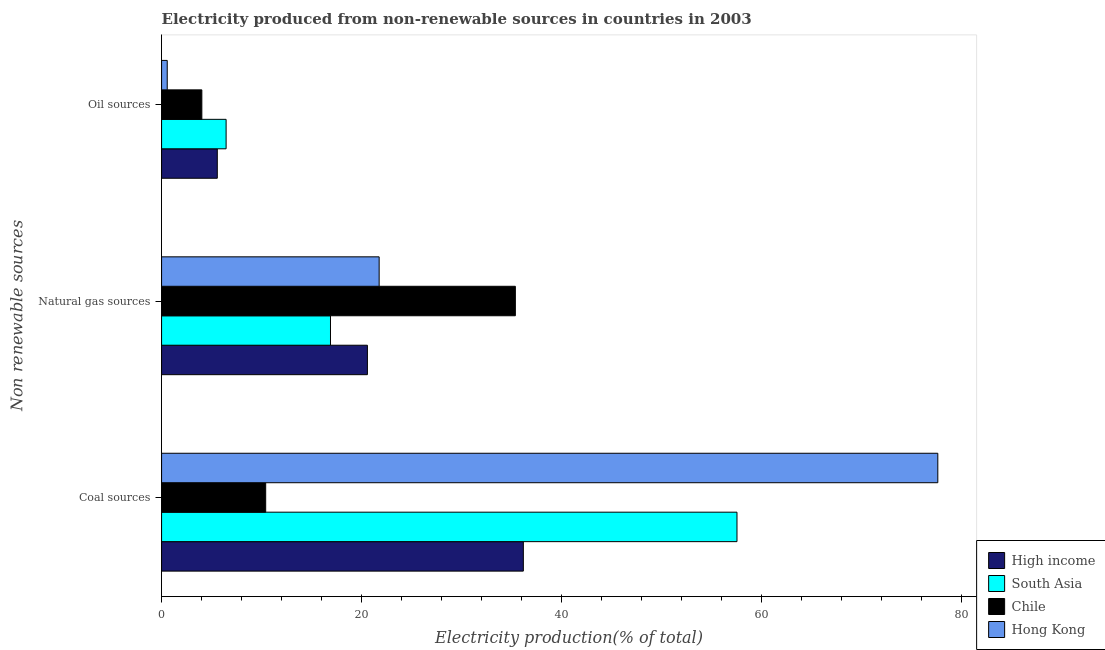How many groups of bars are there?
Give a very brief answer. 3. Are the number of bars on each tick of the Y-axis equal?
Provide a short and direct response. Yes. How many bars are there on the 2nd tick from the top?
Ensure brevity in your answer.  4. What is the label of the 1st group of bars from the top?
Your answer should be very brief. Oil sources. What is the percentage of electricity produced by coal in Chile?
Provide a succinct answer. 10.42. Across all countries, what is the maximum percentage of electricity produced by coal?
Make the answer very short. 77.66. Across all countries, what is the minimum percentage of electricity produced by coal?
Make the answer very short. 10.42. In which country was the percentage of electricity produced by coal maximum?
Provide a short and direct response. Hong Kong. What is the total percentage of electricity produced by natural gas in the graph?
Your answer should be very brief. 94.66. What is the difference between the percentage of electricity produced by coal in Hong Kong and that in High income?
Your response must be concise. 41.47. What is the difference between the percentage of electricity produced by oil sources in South Asia and the percentage of electricity produced by coal in Hong Kong?
Your answer should be very brief. -71.21. What is the average percentage of electricity produced by oil sources per country?
Provide a short and direct response. 4.16. What is the difference between the percentage of electricity produced by coal and percentage of electricity produced by natural gas in South Asia?
Your answer should be compact. 40.67. In how many countries, is the percentage of electricity produced by coal greater than 64 %?
Give a very brief answer. 1. What is the ratio of the percentage of electricity produced by natural gas in South Asia to that in Hong Kong?
Your response must be concise. 0.78. What is the difference between the highest and the second highest percentage of electricity produced by coal?
Your answer should be compact. 20.09. What is the difference between the highest and the lowest percentage of electricity produced by oil sources?
Your answer should be very brief. 5.89. Is the sum of the percentage of electricity produced by coal in Chile and High income greater than the maximum percentage of electricity produced by natural gas across all countries?
Provide a short and direct response. Yes. What does the 1st bar from the top in Coal sources represents?
Ensure brevity in your answer.  Hong Kong. How many countries are there in the graph?
Offer a very short reply. 4. What is the difference between two consecutive major ticks on the X-axis?
Your answer should be very brief. 20. Does the graph contain grids?
Keep it short and to the point. No. What is the title of the graph?
Your answer should be very brief. Electricity produced from non-renewable sources in countries in 2003. What is the label or title of the Y-axis?
Provide a succinct answer. Non renewable sources. What is the Electricity production(% of total) of High income in Coal sources?
Offer a very short reply. 36.2. What is the Electricity production(% of total) in South Asia in Coal sources?
Offer a very short reply. 57.57. What is the Electricity production(% of total) of Chile in Coal sources?
Provide a short and direct response. 10.42. What is the Electricity production(% of total) in Hong Kong in Coal sources?
Your answer should be compact. 77.66. What is the Electricity production(% of total) in High income in Natural gas sources?
Keep it short and to the point. 20.59. What is the Electricity production(% of total) in South Asia in Natural gas sources?
Your answer should be compact. 16.9. What is the Electricity production(% of total) of Chile in Natural gas sources?
Your answer should be very brief. 35.4. What is the Electricity production(% of total) in Hong Kong in Natural gas sources?
Your response must be concise. 21.77. What is the Electricity production(% of total) in High income in Oil sources?
Offer a very short reply. 5.58. What is the Electricity production(% of total) of South Asia in Oil sources?
Provide a short and direct response. 6.46. What is the Electricity production(% of total) in Chile in Oil sources?
Give a very brief answer. 4.03. What is the Electricity production(% of total) of Hong Kong in Oil sources?
Your response must be concise. 0.57. Across all Non renewable sources, what is the maximum Electricity production(% of total) of High income?
Keep it short and to the point. 36.2. Across all Non renewable sources, what is the maximum Electricity production(% of total) in South Asia?
Your response must be concise. 57.57. Across all Non renewable sources, what is the maximum Electricity production(% of total) of Chile?
Keep it short and to the point. 35.4. Across all Non renewable sources, what is the maximum Electricity production(% of total) in Hong Kong?
Offer a very short reply. 77.66. Across all Non renewable sources, what is the minimum Electricity production(% of total) in High income?
Provide a succinct answer. 5.58. Across all Non renewable sources, what is the minimum Electricity production(% of total) of South Asia?
Offer a terse response. 6.46. Across all Non renewable sources, what is the minimum Electricity production(% of total) of Chile?
Give a very brief answer. 4.03. Across all Non renewable sources, what is the minimum Electricity production(% of total) of Hong Kong?
Make the answer very short. 0.57. What is the total Electricity production(% of total) of High income in the graph?
Provide a short and direct response. 62.37. What is the total Electricity production(% of total) of South Asia in the graph?
Your response must be concise. 80.93. What is the total Electricity production(% of total) of Chile in the graph?
Your response must be concise. 49.84. What is the difference between the Electricity production(% of total) of High income in Coal sources and that in Natural gas sources?
Give a very brief answer. 15.6. What is the difference between the Electricity production(% of total) in South Asia in Coal sources and that in Natural gas sources?
Provide a succinct answer. 40.67. What is the difference between the Electricity production(% of total) in Chile in Coal sources and that in Natural gas sources?
Your answer should be compact. -24.98. What is the difference between the Electricity production(% of total) of Hong Kong in Coal sources and that in Natural gas sources?
Provide a short and direct response. 55.9. What is the difference between the Electricity production(% of total) of High income in Coal sources and that in Oil sources?
Provide a succinct answer. 30.62. What is the difference between the Electricity production(% of total) in South Asia in Coal sources and that in Oil sources?
Offer a very short reply. 51.11. What is the difference between the Electricity production(% of total) of Chile in Coal sources and that in Oil sources?
Keep it short and to the point. 6.39. What is the difference between the Electricity production(% of total) in Hong Kong in Coal sources and that in Oil sources?
Make the answer very short. 77.1. What is the difference between the Electricity production(% of total) of High income in Natural gas sources and that in Oil sources?
Your response must be concise. 15.02. What is the difference between the Electricity production(% of total) of South Asia in Natural gas sources and that in Oil sources?
Make the answer very short. 10.44. What is the difference between the Electricity production(% of total) of Chile in Natural gas sources and that in Oil sources?
Give a very brief answer. 31.37. What is the difference between the Electricity production(% of total) in Hong Kong in Natural gas sources and that in Oil sources?
Offer a terse response. 21.2. What is the difference between the Electricity production(% of total) in High income in Coal sources and the Electricity production(% of total) in South Asia in Natural gas sources?
Give a very brief answer. 19.3. What is the difference between the Electricity production(% of total) in High income in Coal sources and the Electricity production(% of total) in Chile in Natural gas sources?
Ensure brevity in your answer.  0.8. What is the difference between the Electricity production(% of total) in High income in Coal sources and the Electricity production(% of total) in Hong Kong in Natural gas sources?
Your answer should be compact. 14.43. What is the difference between the Electricity production(% of total) in South Asia in Coal sources and the Electricity production(% of total) in Chile in Natural gas sources?
Provide a succinct answer. 22.17. What is the difference between the Electricity production(% of total) in South Asia in Coal sources and the Electricity production(% of total) in Hong Kong in Natural gas sources?
Keep it short and to the point. 35.8. What is the difference between the Electricity production(% of total) in Chile in Coal sources and the Electricity production(% of total) in Hong Kong in Natural gas sources?
Your answer should be very brief. -11.35. What is the difference between the Electricity production(% of total) of High income in Coal sources and the Electricity production(% of total) of South Asia in Oil sources?
Provide a short and direct response. 29.74. What is the difference between the Electricity production(% of total) in High income in Coal sources and the Electricity production(% of total) in Chile in Oil sources?
Offer a very short reply. 32.17. What is the difference between the Electricity production(% of total) of High income in Coal sources and the Electricity production(% of total) of Hong Kong in Oil sources?
Ensure brevity in your answer.  35.63. What is the difference between the Electricity production(% of total) in South Asia in Coal sources and the Electricity production(% of total) in Chile in Oil sources?
Give a very brief answer. 53.54. What is the difference between the Electricity production(% of total) in South Asia in Coal sources and the Electricity production(% of total) in Hong Kong in Oil sources?
Your answer should be very brief. 57.01. What is the difference between the Electricity production(% of total) in Chile in Coal sources and the Electricity production(% of total) in Hong Kong in Oil sources?
Offer a very short reply. 9.85. What is the difference between the Electricity production(% of total) of High income in Natural gas sources and the Electricity production(% of total) of South Asia in Oil sources?
Your answer should be compact. 14.14. What is the difference between the Electricity production(% of total) in High income in Natural gas sources and the Electricity production(% of total) in Chile in Oil sources?
Offer a very short reply. 16.57. What is the difference between the Electricity production(% of total) of High income in Natural gas sources and the Electricity production(% of total) of Hong Kong in Oil sources?
Offer a terse response. 20.03. What is the difference between the Electricity production(% of total) of South Asia in Natural gas sources and the Electricity production(% of total) of Chile in Oil sources?
Offer a terse response. 12.87. What is the difference between the Electricity production(% of total) in South Asia in Natural gas sources and the Electricity production(% of total) in Hong Kong in Oil sources?
Your answer should be compact. 16.33. What is the difference between the Electricity production(% of total) in Chile in Natural gas sources and the Electricity production(% of total) in Hong Kong in Oil sources?
Provide a succinct answer. 34.83. What is the average Electricity production(% of total) in High income per Non renewable sources?
Your answer should be very brief. 20.79. What is the average Electricity production(% of total) of South Asia per Non renewable sources?
Offer a very short reply. 26.98. What is the average Electricity production(% of total) in Chile per Non renewable sources?
Offer a very short reply. 16.61. What is the average Electricity production(% of total) of Hong Kong per Non renewable sources?
Your answer should be very brief. 33.33. What is the difference between the Electricity production(% of total) in High income and Electricity production(% of total) in South Asia in Coal sources?
Your answer should be compact. -21.38. What is the difference between the Electricity production(% of total) of High income and Electricity production(% of total) of Chile in Coal sources?
Provide a succinct answer. 25.78. What is the difference between the Electricity production(% of total) of High income and Electricity production(% of total) of Hong Kong in Coal sources?
Offer a very short reply. -41.47. What is the difference between the Electricity production(% of total) in South Asia and Electricity production(% of total) in Chile in Coal sources?
Keep it short and to the point. 47.15. What is the difference between the Electricity production(% of total) in South Asia and Electricity production(% of total) in Hong Kong in Coal sources?
Your response must be concise. -20.09. What is the difference between the Electricity production(% of total) of Chile and Electricity production(% of total) of Hong Kong in Coal sources?
Give a very brief answer. -67.25. What is the difference between the Electricity production(% of total) of High income and Electricity production(% of total) of South Asia in Natural gas sources?
Your answer should be very brief. 3.7. What is the difference between the Electricity production(% of total) in High income and Electricity production(% of total) in Chile in Natural gas sources?
Offer a terse response. -14.8. What is the difference between the Electricity production(% of total) in High income and Electricity production(% of total) in Hong Kong in Natural gas sources?
Provide a succinct answer. -1.17. What is the difference between the Electricity production(% of total) of South Asia and Electricity production(% of total) of Chile in Natural gas sources?
Give a very brief answer. -18.5. What is the difference between the Electricity production(% of total) in South Asia and Electricity production(% of total) in Hong Kong in Natural gas sources?
Offer a terse response. -4.87. What is the difference between the Electricity production(% of total) of Chile and Electricity production(% of total) of Hong Kong in Natural gas sources?
Ensure brevity in your answer.  13.63. What is the difference between the Electricity production(% of total) of High income and Electricity production(% of total) of South Asia in Oil sources?
Offer a very short reply. -0.88. What is the difference between the Electricity production(% of total) in High income and Electricity production(% of total) in Chile in Oil sources?
Make the answer very short. 1.55. What is the difference between the Electricity production(% of total) of High income and Electricity production(% of total) of Hong Kong in Oil sources?
Provide a short and direct response. 5.01. What is the difference between the Electricity production(% of total) of South Asia and Electricity production(% of total) of Chile in Oil sources?
Your answer should be very brief. 2.43. What is the difference between the Electricity production(% of total) of South Asia and Electricity production(% of total) of Hong Kong in Oil sources?
Give a very brief answer. 5.89. What is the difference between the Electricity production(% of total) in Chile and Electricity production(% of total) in Hong Kong in Oil sources?
Offer a terse response. 3.46. What is the ratio of the Electricity production(% of total) of High income in Coal sources to that in Natural gas sources?
Ensure brevity in your answer.  1.76. What is the ratio of the Electricity production(% of total) of South Asia in Coal sources to that in Natural gas sources?
Your answer should be very brief. 3.41. What is the ratio of the Electricity production(% of total) in Chile in Coal sources to that in Natural gas sources?
Give a very brief answer. 0.29. What is the ratio of the Electricity production(% of total) in Hong Kong in Coal sources to that in Natural gas sources?
Ensure brevity in your answer.  3.57. What is the ratio of the Electricity production(% of total) of High income in Coal sources to that in Oil sources?
Make the answer very short. 6.49. What is the ratio of the Electricity production(% of total) of South Asia in Coal sources to that in Oil sources?
Offer a terse response. 8.92. What is the ratio of the Electricity production(% of total) in Chile in Coal sources to that in Oil sources?
Your answer should be very brief. 2.59. What is the ratio of the Electricity production(% of total) in Hong Kong in Coal sources to that in Oil sources?
Offer a very short reply. 137.2. What is the ratio of the Electricity production(% of total) in High income in Natural gas sources to that in Oil sources?
Offer a very short reply. 3.69. What is the ratio of the Electricity production(% of total) in South Asia in Natural gas sources to that in Oil sources?
Keep it short and to the point. 2.62. What is the ratio of the Electricity production(% of total) of Chile in Natural gas sources to that in Oil sources?
Keep it short and to the point. 8.78. What is the ratio of the Electricity production(% of total) of Hong Kong in Natural gas sources to that in Oil sources?
Keep it short and to the point. 38.46. What is the difference between the highest and the second highest Electricity production(% of total) in High income?
Provide a short and direct response. 15.6. What is the difference between the highest and the second highest Electricity production(% of total) of South Asia?
Provide a short and direct response. 40.67. What is the difference between the highest and the second highest Electricity production(% of total) of Chile?
Your answer should be compact. 24.98. What is the difference between the highest and the second highest Electricity production(% of total) of Hong Kong?
Give a very brief answer. 55.9. What is the difference between the highest and the lowest Electricity production(% of total) in High income?
Your answer should be very brief. 30.62. What is the difference between the highest and the lowest Electricity production(% of total) of South Asia?
Make the answer very short. 51.11. What is the difference between the highest and the lowest Electricity production(% of total) of Chile?
Make the answer very short. 31.37. What is the difference between the highest and the lowest Electricity production(% of total) in Hong Kong?
Offer a terse response. 77.1. 